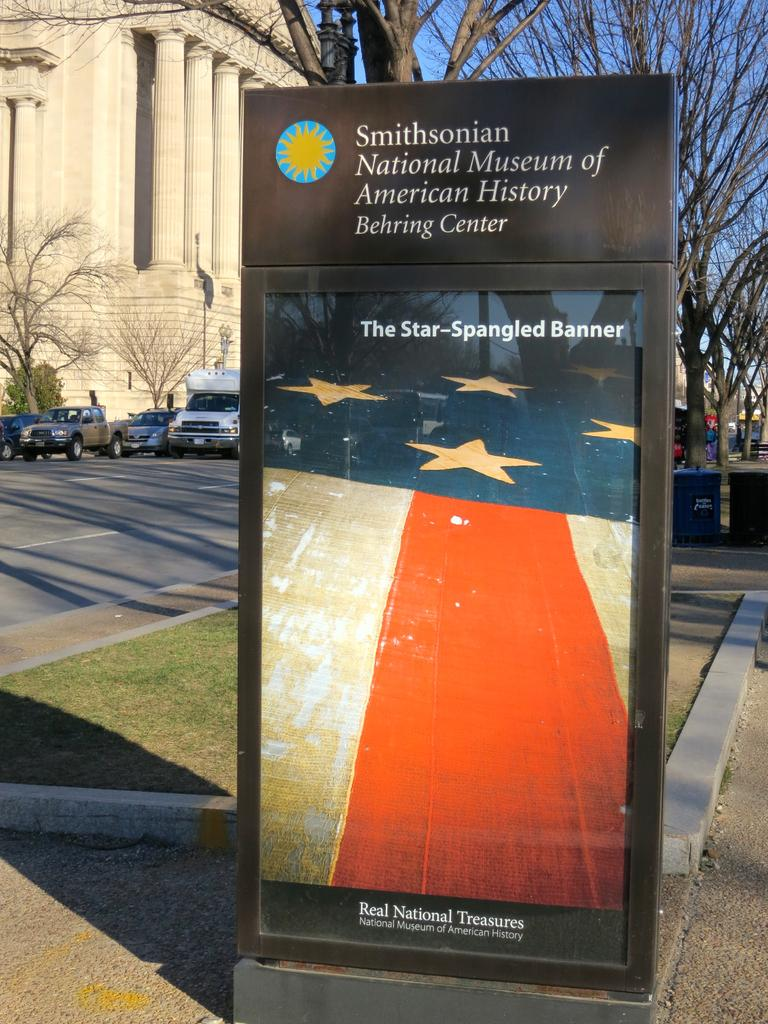<image>
Render a clear and concise summary of the photo. An advertisement for a Smithsonian museum shows a picture of the American flag. 